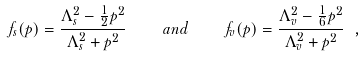<formula> <loc_0><loc_0><loc_500><loc_500>f _ { s } ( p ) = \frac { \Lambda _ { s } ^ { 2 } - \frac { 1 } { 2 } p ^ { 2 } } { \Lambda _ { s } ^ { 2 } + p ^ { 2 } } \quad a n d \quad f _ { v } ( p ) = \frac { \Lambda _ { v } ^ { 2 } - \frac { 1 } { 6 } p ^ { 2 } } { \Lambda _ { v } ^ { 2 } + p ^ { 2 } } \ ,</formula> 